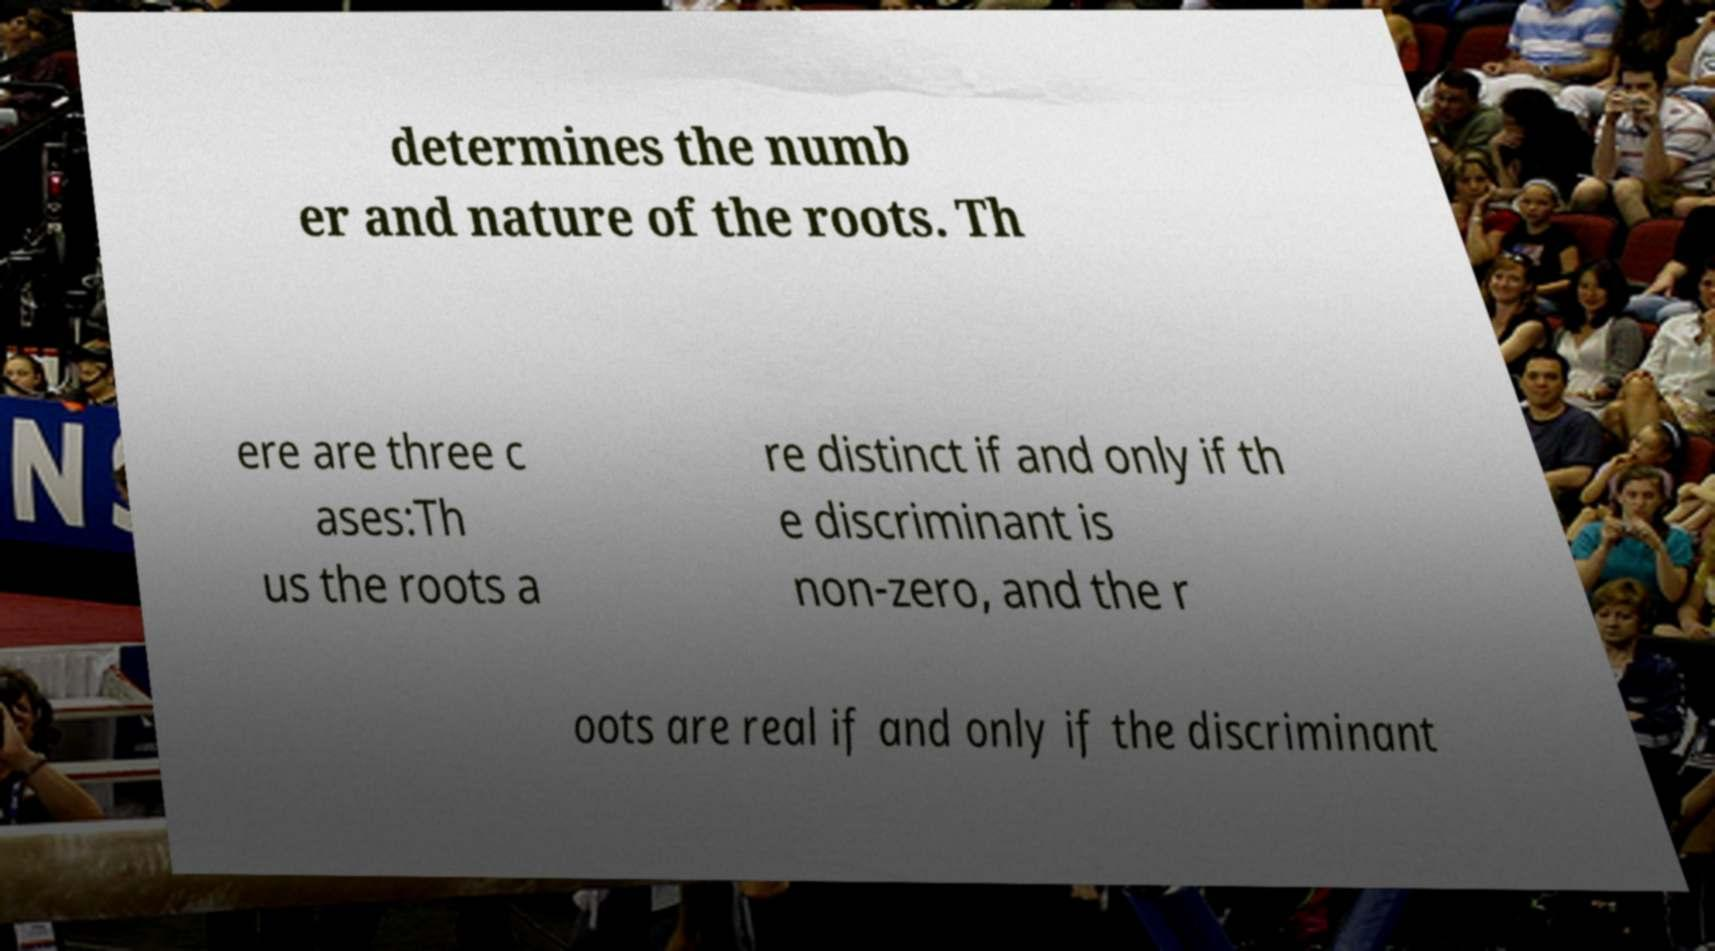There's text embedded in this image that I need extracted. Can you transcribe it verbatim? determines the numb er and nature of the roots. Th ere are three c ases:Th us the roots a re distinct if and only if th e discriminant is non-zero, and the r oots are real if and only if the discriminant 